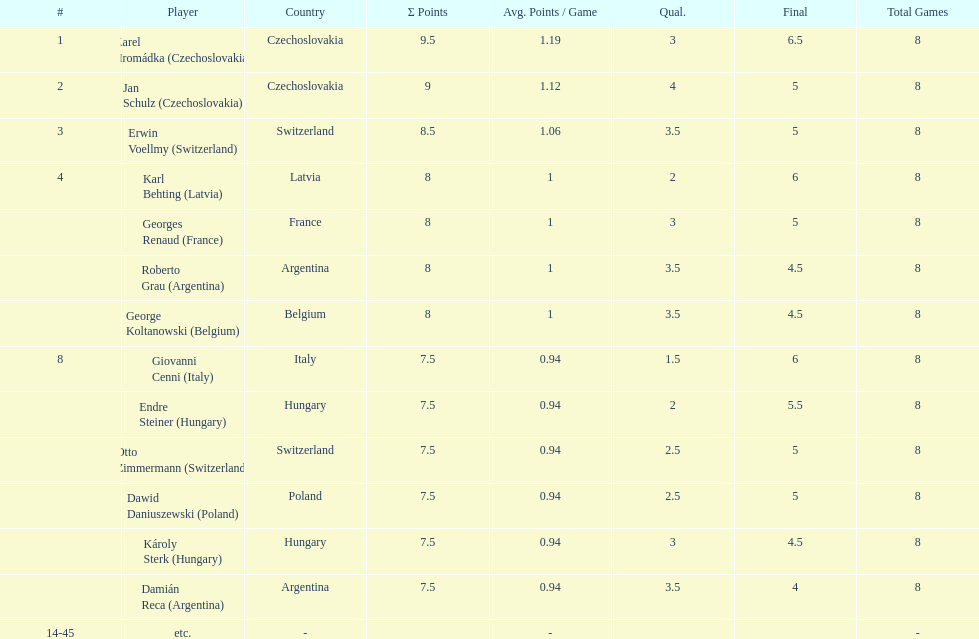Karl behting and giovanni cenni each had final scores of what? 6. 